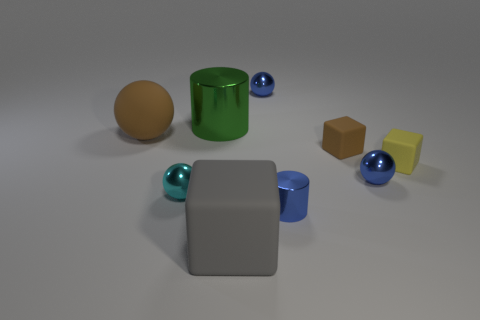There is a metal cylinder that is behind the shiny cylinder to the right of the tiny blue sphere behind the large brown matte sphere; what is its color?
Make the answer very short. Green. Is there anything else that has the same shape as the gray object?
Offer a terse response. Yes. Is the number of tiny cyan shiny objects greater than the number of tiny blue blocks?
Your response must be concise. Yes. How many rubber things are behind the yellow matte thing and on the right side of the large shiny thing?
Your response must be concise. 1. How many balls are on the left side of the blue ball in front of the large green cylinder?
Your answer should be compact. 3. Do the cylinder that is to the right of the large cube and the brown rubber object that is to the right of the cyan object have the same size?
Offer a very short reply. Yes. How many tiny blue objects are there?
Give a very brief answer. 3. How many small yellow cylinders are made of the same material as the large green cylinder?
Your answer should be very brief. 0. Are there an equal number of gray rubber things that are behind the gray block and tiny brown blocks?
Keep it short and to the point. No. There is a small object that is the same color as the big ball; what is its material?
Your response must be concise. Rubber. 